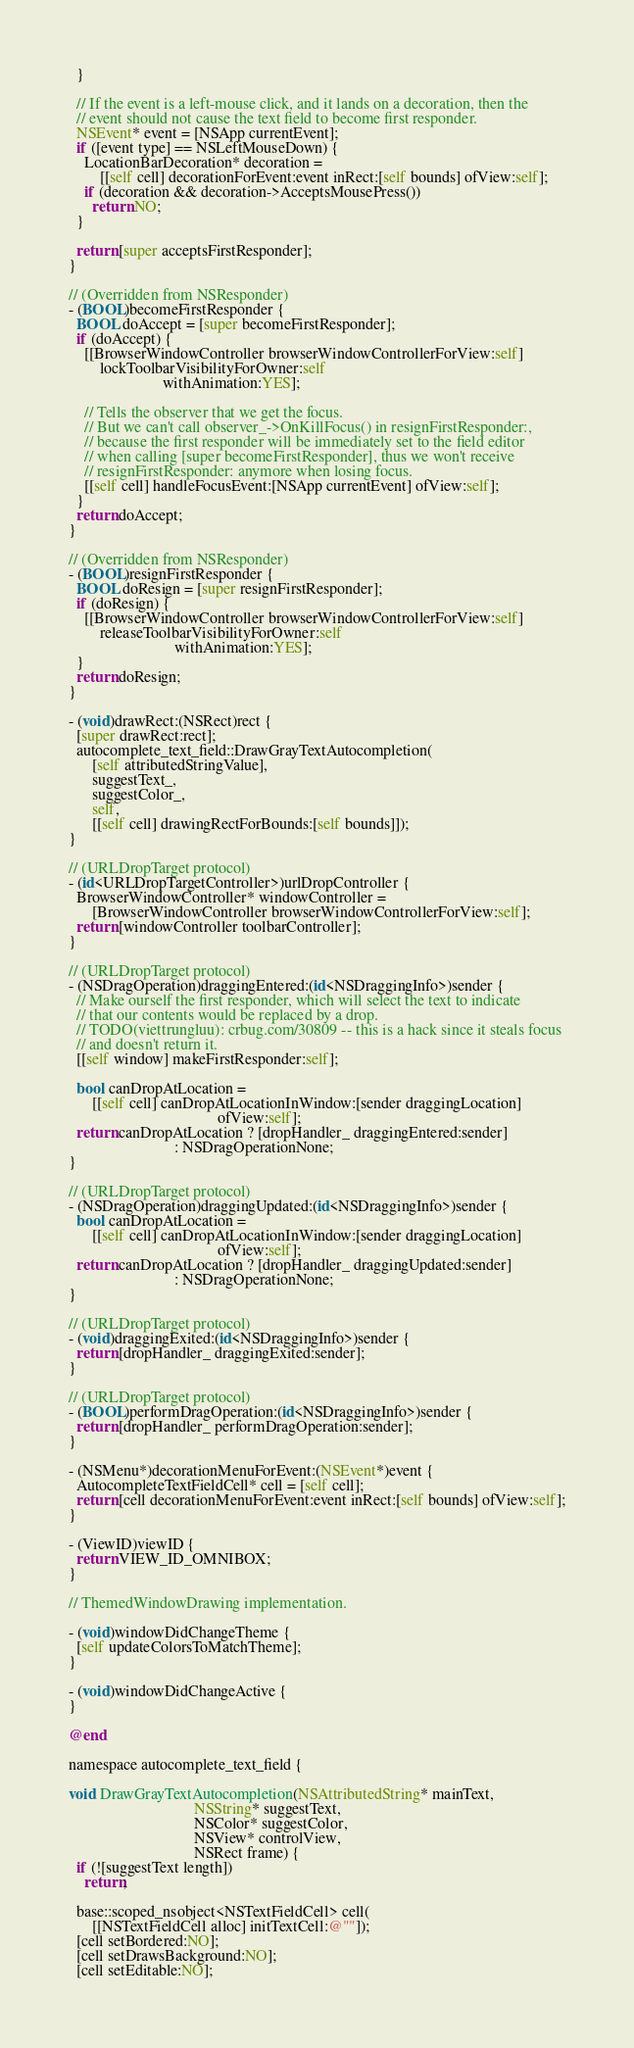Convert code to text. <code><loc_0><loc_0><loc_500><loc_500><_ObjectiveC_>  }

  // If the event is a left-mouse click, and it lands on a decoration, then the
  // event should not cause the text field to become first responder.
  NSEvent* event = [NSApp currentEvent];
  if ([event type] == NSLeftMouseDown) {
    LocationBarDecoration* decoration =
        [[self cell] decorationForEvent:event inRect:[self bounds] ofView:self];
    if (decoration && decoration->AcceptsMousePress())
      return NO;
  }

  return [super acceptsFirstResponder];
}

// (Overridden from NSResponder)
- (BOOL)becomeFirstResponder {
  BOOL doAccept = [super becomeFirstResponder];
  if (doAccept) {
    [[BrowserWindowController browserWindowControllerForView:self]
        lockToolbarVisibilityForOwner:self
                        withAnimation:YES];

    // Tells the observer that we get the focus.
    // But we can't call observer_->OnKillFocus() in resignFirstResponder:,
    // because the first responder will be immediately set to the field editor
    // when calling [super becomeFirstResponder], thus we won't receive
    // resignFirstResponder: anymore when losing focus.
    [[self cell] handleFocusEvent:[NSApp currentEvent] ofView:self];
  }
  return doAccept;
}

// (Overridden from NSResponder)
- (BOOL)resignFirstResponder {
  BOOL doResign = [super resignFirstResponder];
  if (doResign) {
    [[BrowserWindowController browserWindowControllerForView:self]
        releaseToolbarVisibilityForOwner:self
                           withAnimation:YES];
  }
  return doResign;
}

- (void)drawRect:(NSRect)rect {
  [super drawRect:rect];
  autocomplete_text_field::DrawGrayTextAutocompletion(
      [self attributedStringValue],
      suggestText_,
      suggestColor_,
      self,
      [[self cell] drawingRectForBounds:[self bounds]]);
}

// (URLDropTarget protocol)
- (id<URLDropTargetController>)urlDropController {
  BrowserWindowController* windowController =
      [BrowserWindowController browserWindowControllerForView:self];
  return [windowController toolbarController];
}

// (URLDropTarget protocol)
- (NSDragOperation)draggingEntered:(id<NSDraggingInfo>)sender {
  // Make ourself the first responder, which will select the text to indicate
  // that our contents would be replaced by a drop.
  // TODO(viettrungluu): crbug.com/30809 -- this is a hack since it steals focus
  // and doesn't return it.
  [[self window] makeFirstResponder:self];

  bool canDropAtLocation =
      [[self cell] canDropAtLocationInWindow:[sender draggingLocation]
                                      ofView:self];
  return canDropAtLocation ? [dropHandler_ draggingEntered:sender]
                           : NSDragOperationNone;
}

// (URLDropTarget protocol)
- (NSDragOperation)draggingUpdated:(id<NSDraggingInfo>)sender {
  bool canDropAtLocation =
      [[self cell] canDropAtLocationInWindow:[sender draggingLocation]
                                      ofView:self];
  return canDropAtLocation ? [dropHandler_ draggingUpdated:sender]
                           : NSDragOperationNone;
}

// (URLDropTarget protocol)
- (void)draggingExited:(id<NSDraggingInfo>)sender {
  return [dropHandler_ draggingExited:sender];
}

// (URLDropTarget protocol)
- (BOOL)performDragOperation:(id<NSDraggingInfo>)sender {
  return [dropHandler_ performDragOperation:sender];
}

- (NSMenu*)decorationMenuForEvent:(NSEvent*)event {
  AutocompleteTextFieldCell* cell = [self cell];
  return [cell decorationMenuForEvent:event inRect:[self bounds] ofView:self];
}

- (ViewID)viewID {
  return VIEW_ID_OMNIBOX;
}

// ThemedWindowDrawing implementation.

- (void)windowDidChangeTheme {
  [self updateColorsToMatchTheme];
}

- (void)windowDidChangeActive {
}

@end

namespace autocomplete_text_field {

void DrawGrayTextAutocompletion(NSAttributedString* mainText,
                                NSString* suggestText,
                                NSColor* suggestColor,
                                NSView* controlView,
                                NSRect frame) {
  if (![suggestText length])
    return;

  base::scoped_nsobject<NSTextFieldCell> cell(
      [[NSTextFieldCell alloc] initTextCell:@""]);
  [cell setBordered:NO];
  [cell setDrawsBackground:NO];
  [cell setEditable:NO];
</code> 